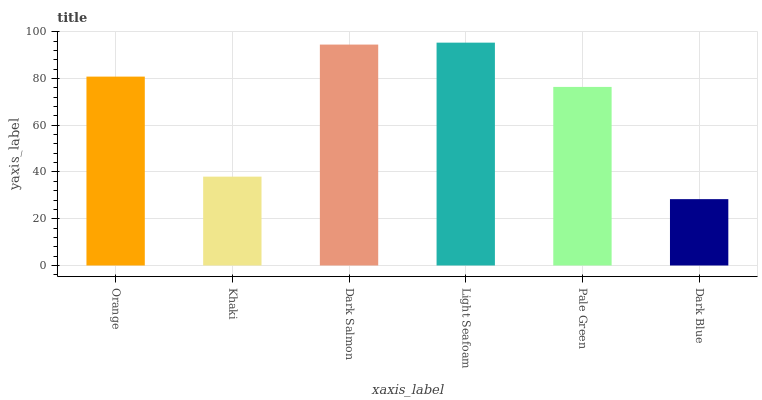Is Khaki the minimum?
Answer yes or no. No. Is Khaki the maximum?
Answer yes or no. No. Is Orange greater than Khaki?
Answer yes or no. Yes. Is Khaki less than Orange?
Answer yes or no. Yes. Is Khaki greater than Orange?
Answer yes or no. No. Is Orange less than Khaki?
Answer yes or no. No. Is Orange the high median?
Answer yes or no. Yes. Is Pale Green the low median?
Answer yes or no. Yes. Is Khaki the high median?
Answer yes or no. No. Is Light Seafoam the low median?
Answer yes or no. No. 